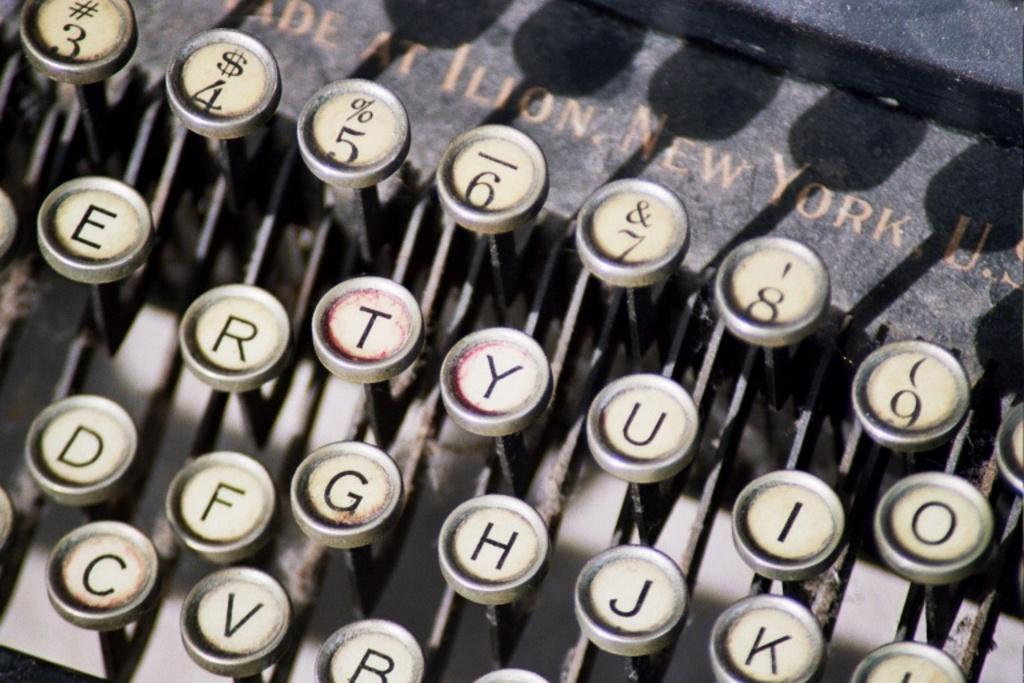<image>
Offer a succinct explanation of the picture presented. A vintage made in New York U.S. typewriter. 